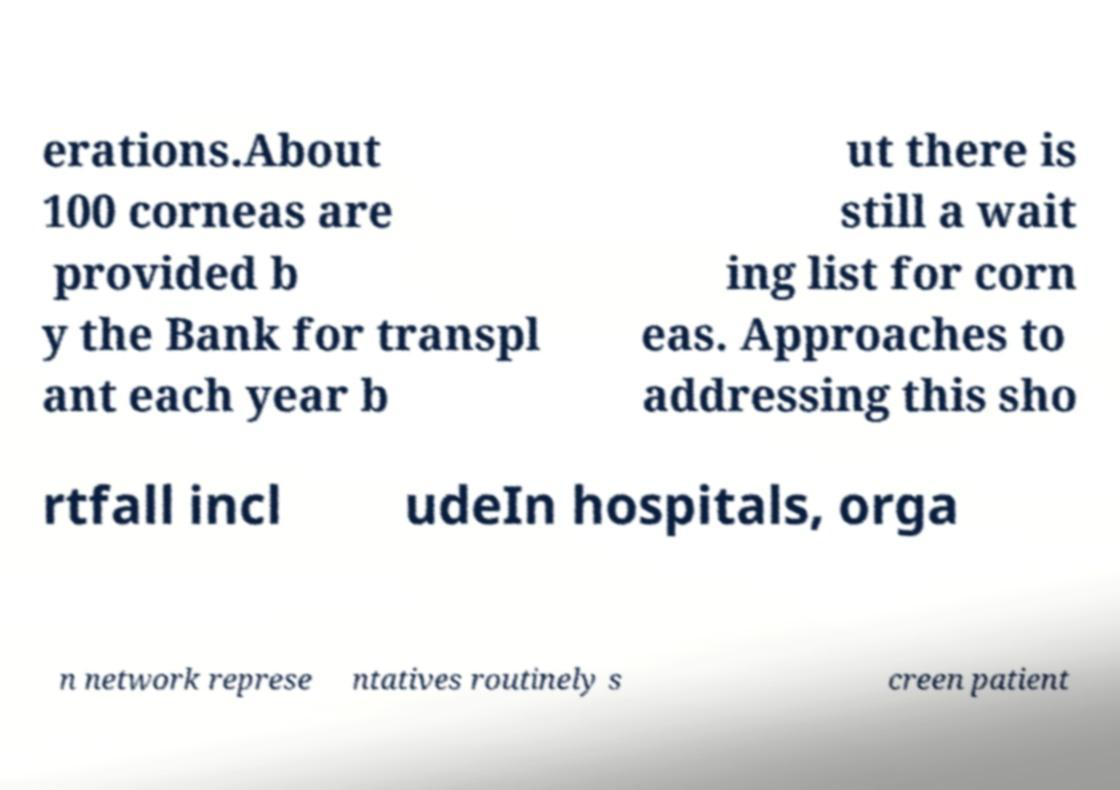Could you assist in decoding the text presented in this image and type it out clearly? erations.About 100 corneas are provided b y the Bank for transpl ant each year b ut there is still a wait ing list for corn eas. Approaches to addressing this sho rtfall incl udeIn hospitals, orga n network represe ntatives routinely s creen patient 